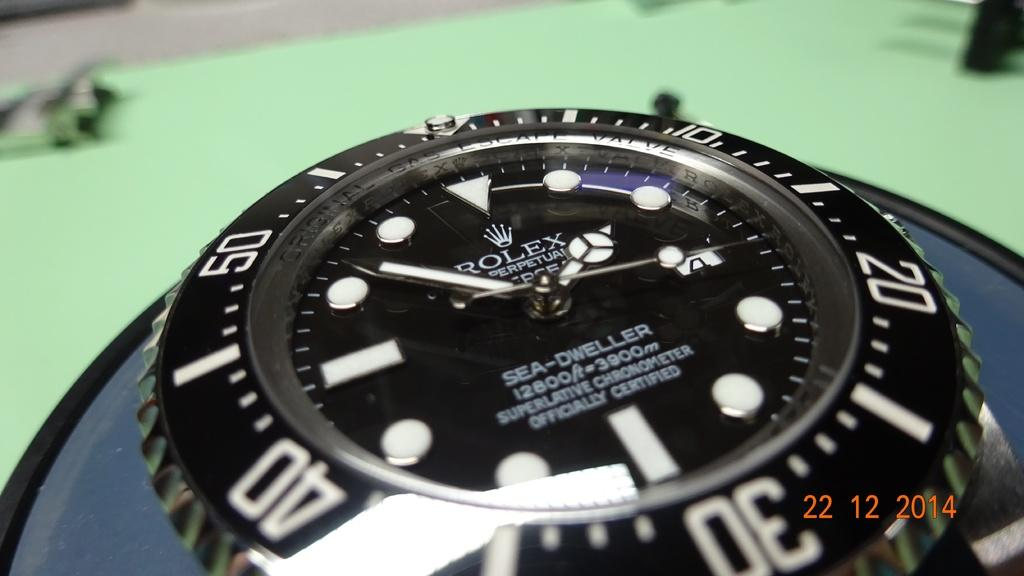<image>
Provide a brief description of the given image. A rolex watch displaying the time of 1:52 